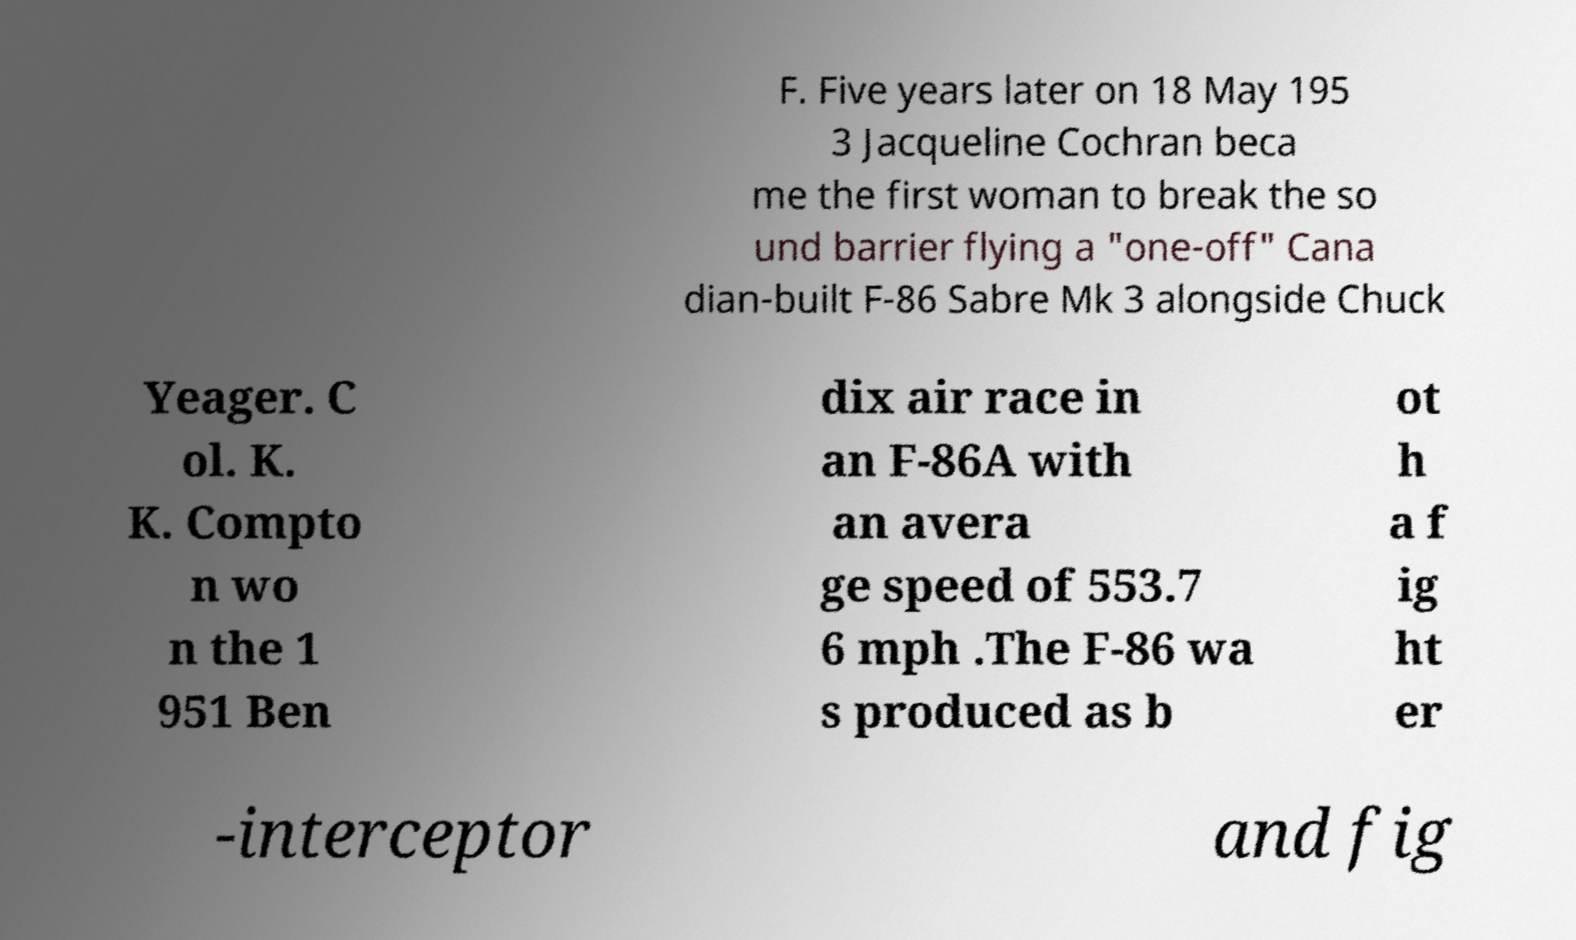Could you extract and type out the text from this image? F. Five years later on 18 May 195 3 Jacqueline Cochran beca me the first woman to break the so und barrier flying a "one-off" Cana dian-built F-86 Sabre Mk 3 alongside Chuck Yeager. C ol. K. K. Compto n wo n the 1 951 Ben dix air race in an F-86A with an avera ge speed of 553.7 6 mph .The F-86 wa s produced as b ot h a f ig ht er -interceptor and fig 